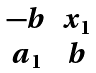Convert formula to latex. <formula><loc_0><loc_0><loc_500><loc_500>\begin{matrix} - b & x _ { 1 } \\ a _ { 1 } & b \end{matrix}</formula> 